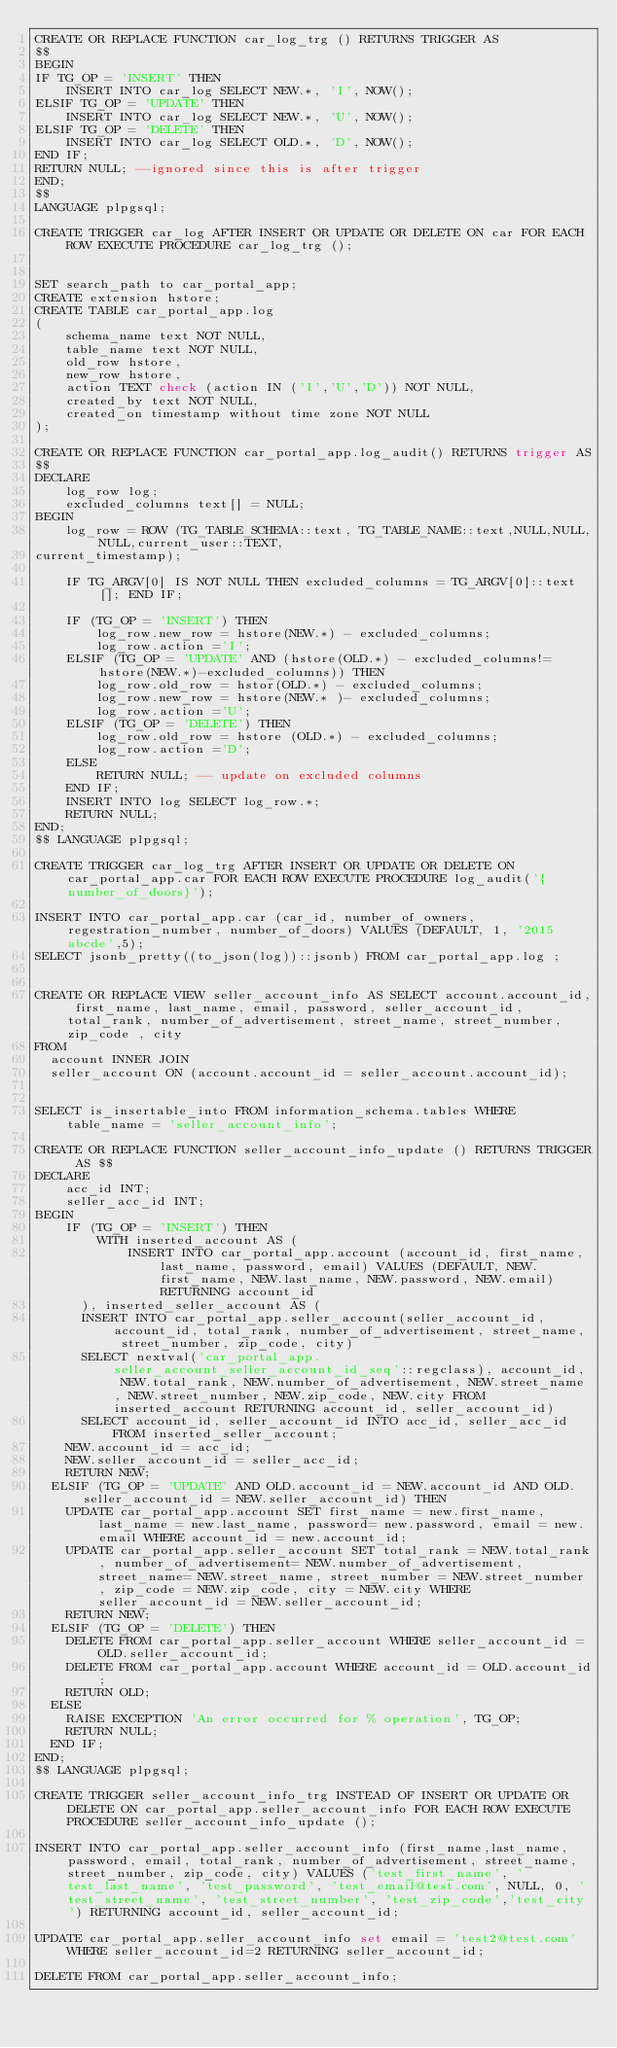<code> <loc_0><loc_0><loc_500><loc_500><_SQL_>CREATE OR REPLACE FUNCTION car_log_trg () RETURNS TRIGGER AS
$$
BEGIN
IF TG_OP = 'INSERT' THEN
		INSERT INTO car_log SELECT NEW.*, 'I', NOW();
ELSIF TG_OP = 'UPDATE' THEN
		INSERT INTO car_log SELECT NEW.*, 'U', NOW();
ELSIF TG_OP = 'DELETE' THEN
		INSERT INTO car_log SELECT OLD.*, 'D', NOW();
END IF;
RETURN NULL; --ignored since this is after trigger
END;
$$
LANGUAGE plpgsql;

CREATE TRIGGER car_log AFTER INSERT OR UPDATE OR DELETE ON car FOR EACH ROW EXECUTE PROCEDURE car_log_trg ();


SET search_path to car_portal_app;
CREATE extension hstore;
CREATE TABLE car_portal_app.log
(
		schema_name text NOT NULL,
		table_name text NOT NULL,
		old_row hstore,
		new_row hstore,
		action TEXT check (action IN ('I','U','D')) NOT NULL,
		created_by text NOT NULL,
		created_on timestamp without time zone NOT NULL
);

CREATE OR REPLACE FUNCTION car_portal_app.log_audit() RETURNS trigger AS
$$
DECLARE
		log_row log;
		excluded_columns text[] = NULL;
BEGIN
		log_row = ROW (TG_TABLE_SCHEMA::text, TG_TABLE_NAME::text,NULL,NULL,NULL,current_user::TEXT,
current_timestamp);

		IF TG_ARGV[0] IS NOT NULL THEN excluded_columns = TG_ARGV[0]::text[]; END IF;

		IF (TG_OP = 'INSERT') THEN
				log_row.new_row = hstore(NEW.*) - excluded_columns;
				log_row.action ='I';
		ELSIF (TG_OP = 'UPDATE' AND (hstore(OLD.*) - excluded_columns!= hstore(NEW.*)-excluded_columns)) THEN
				log_row.old_row = hstor(OLD.*) - excluded_columns;
				log_row.new_row = hstore(NEW.* )- excluded_columns;
				log_row.action ='U';
		ELSIF (TG_OP = 'DELETE') THEN
				log_row.old_row = hstore (OLD.*) - excluded_columns;
				log_row.action ='D';
		ELSE
				RETURN NULL; -- update on excluded columns
		END IF;
		INSERT INTO log SELECT log_row.*;
		RETURN NULL;
END;
$$ LANGUAGE plpgsql;

CREATE TRIGGER car_log_trg AFTER INSERT OR UPDATE OR DELETE ON car_portal_app.car FOR EACH ROW EXECUTE PROCEDURE log_audit('{number_of_doors}');

INSERT INTO car_portal_app.car (car_id, number_of_owners, regestration_number, number_of_doors) VALUES (DEFAULT, 1, '2015abcde',5);
SELECT jsonb_pretty((to_json(log))::jsonb) FROM car_portal_app.log ;


CREATE OR REPLACE VIEW seller_account_info AS SELECT account.account_id, first_name, last_name, email, password, seller_account_id, total_rank, number_of_advertisement, street_name, street_number, zip_code , city
FROM
	account INNER JOIN
	seller_account ON (account.account_id = seller_account.account_id);


SELECT is_insertable_into FROM information_schema.tables WHERE table_name = 'seller_account_info';

CREATE OR REPLACE FUNCTION seller_account_info_update () RETURNS TRIGGER AS $$
DECLARE
		acc_id INT;
		seller_acc_id INT;
BEGIN
		IF (TG_OP = 'INSERT') THEN
				WITH inserted_account AS (
						INSERT INTO car_portal_app.account (account_id, first_name, last_name, password, email) VALUES (DEFAULT, NEW.first_name, NEW.last_name, NEW.password, NEW.email) RETURNING account_id
			), inserted_seller_account AS (
			INSERT INTO car_portal_app.seller_account(seller_account_id, account_id, total_rank, number_of_advertisement, street_name, street_number, zip_code, city)
			SELECT nextval('car_portal_app.seller_account_seller_account_id_seq'::regclass), account_id, NEW.total_rank, NEW.number_of_advertisement, NEW.street_name, NEW.street_number, NEW.zip_code, NEW.city FROM inserted_account RETURNING account_id, seller_account_id)
			SELECT account_id, seller_account_id INTO acc_id, seller_acc_id FROM inserted_seller_account;
		NEW.account_id = acc_id;
		NEW.seller_account_id = seller_acc_id;
		RETURN NEW;
	ELSIF (TG_OP = 'UPDATE' AND OLD.account_id = NEW.account_id AND OLD.seller_account_id = NEW.seller_account_id) THEN
		UPDATE car_portal_app.account SET first_name = new.first_name, last_name = new.last_name, password= new.password, email = new.email WHERE account_id = new.account_id;
		UPDATE car_portal_app.seller_account SET total_rank = NEW.total_rank, number_of_advertisement= NEW.number_of_advertisement, street_name= NEW.street_name, street_number = NEW.street_number, zip_code = NEW.zip_code, city = NEW.city WHERE seller_account_id = NEW.seller_account_id;
		RETURN NEW;
	ELSIF (TG_OP = 'DELETE') THEN
		DELETE FROM car_portal_app.seller_account WHERE seller_account_id = OLD.seller_account_id;
		DELETE FROM car_portal_app.account WHERE account_id = OLD.account_id;
		RETURN OLD;
	ELSE
		RAISE EXCEPTION 'An error occurred for % operation', TG_OP;
		RETURN NULL;
	END IF;
END;
$$ LANGUAGE plpgsql;

CREATE TRIGGER seller_account_info_trg INSTEAD OF INSERT OR UPDATE OR DELETE ON car_portal_app.seller_account_info FOR EACH ROW EXECUTE PROCEDURE seller_account_info_update ();

INSERT INTO car_portal_app.seller_account_info (first_name,last_name, password, email, total_rank, number_of_advertisement, street_name, street_number, zip_code, city) VALUES ('test_first_name', 'test_last_name', 'test_password', 'test_email@test.com', NULL, 0, 'test_street_name', 'test_street_number', 'test_zip_code','test_city') RETURNING account_id, seller_account_id;

UPDATE car_portal_app.seller_account_info set email = 'test2@test.com' WHERE seller_account_id=2 RETURNING seller_account_id;

DELETE FROM car_portal_app.seller_account_info;
</code> 